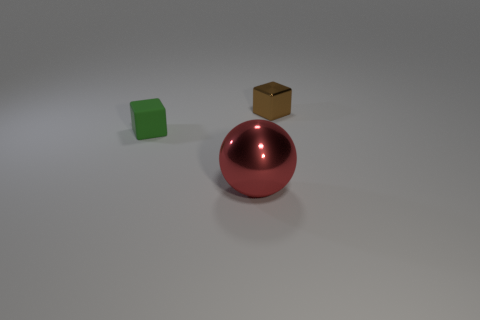There is a green thing that is the same size as the brown metal thing; what is its shape? The green object has a cylindrical shape with circular faces on the top and bottom and a curved surface connecting them. 